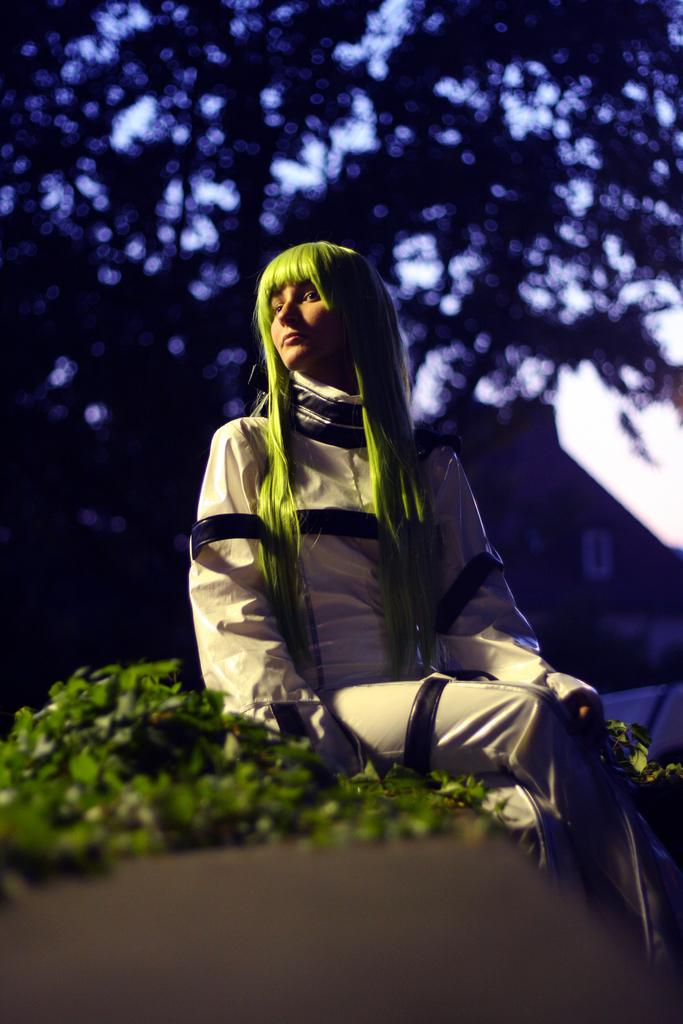What is the woman in the image doing? The woman is sitting on a surface in the image. What can be seen in the image besides the woman? There are plants, trees, a house, and the sky visible in the image. Can you describe the natural elements in the image? The image features plants and trees. What is visible in the background of the image? The sky is visible in the background of the image. What type of ship can be seen in the image? There is no ship present in the image. What kind of treatment is the woman receiving in the image? The image does not depict any treatment being administered to the woman. 